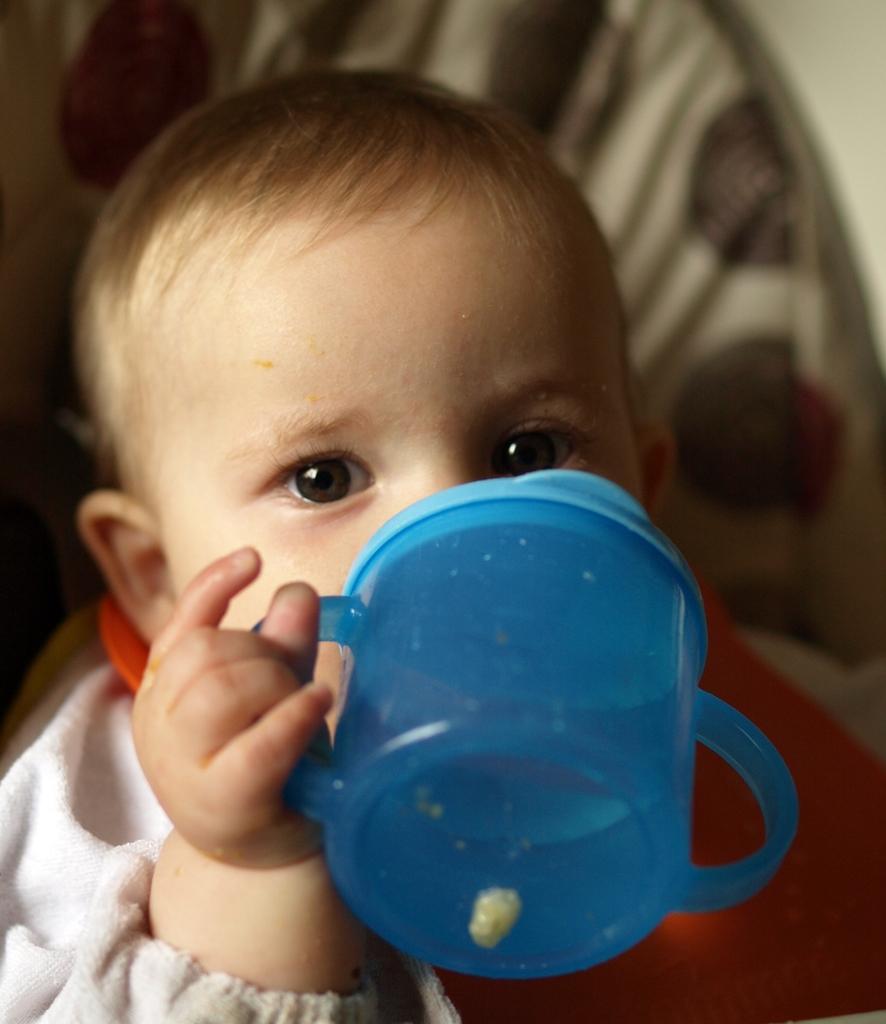How would you summarize this image in a sentence or two? In this image there is a kid. He is holding a zipper in his hand. 